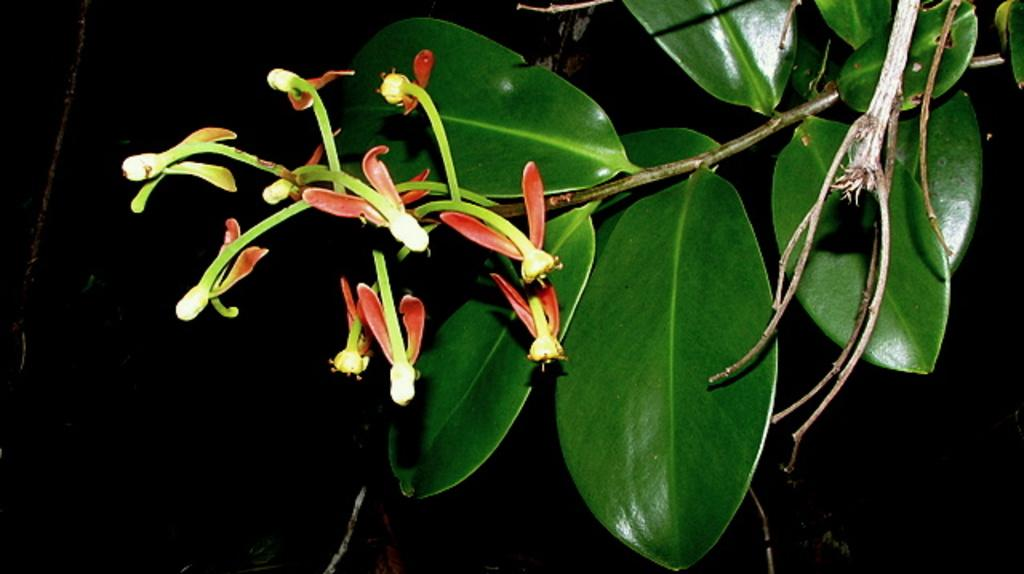What type of plants can be seen in the image? There are flowers and leaves in the image. Where are the flowers and leaves located in the image? The flowers and leaves are in the center of the image. How is the bait used in the image? There is no bait present in the image. What is being pulled in the image? There is no pulling action depicted in the image. 